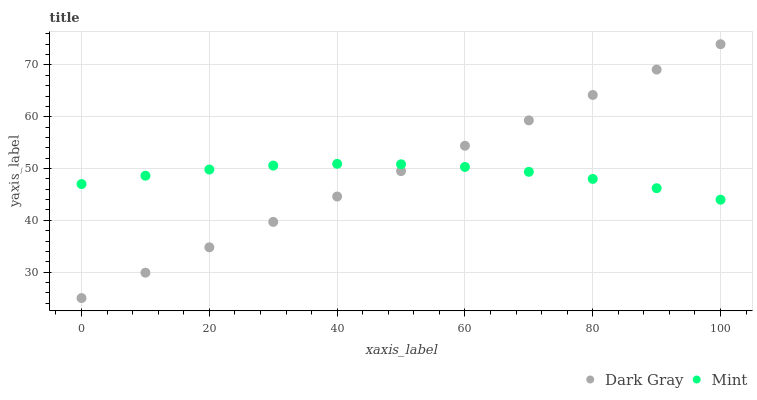Does Mint have the minimum area under the curve?
Answer yes or no. Yes. Does Dark Gray have the maximum area under the curve?
Answer yes or no. Yes. Does Mint have the maximum area under the curve?
Answer yes or no. No. Is Dark Gray the smoothest?
Answer yes or no. Yes. Is Mint the roughest?
Answer yes or no. Yes. Is Mint the smoothest?
Answer yes or no. No. Does Dark Gray have the lowest value?
Answer yes or no. Yes. Does Mint have the lowest value?
Answer yes or no. No. Does Dark Gray have the highest value?
Answer yes or no. Yes. Does Mint have the highest value?
Answer yes or no. No. Does Dark Gray intersect Mint?
Answer yes or no. Yes. Is Dark Gray less than Mint?
Answer yes or no. No. Is Dark Gray greater than Mint?
Answer yes or no. No. 